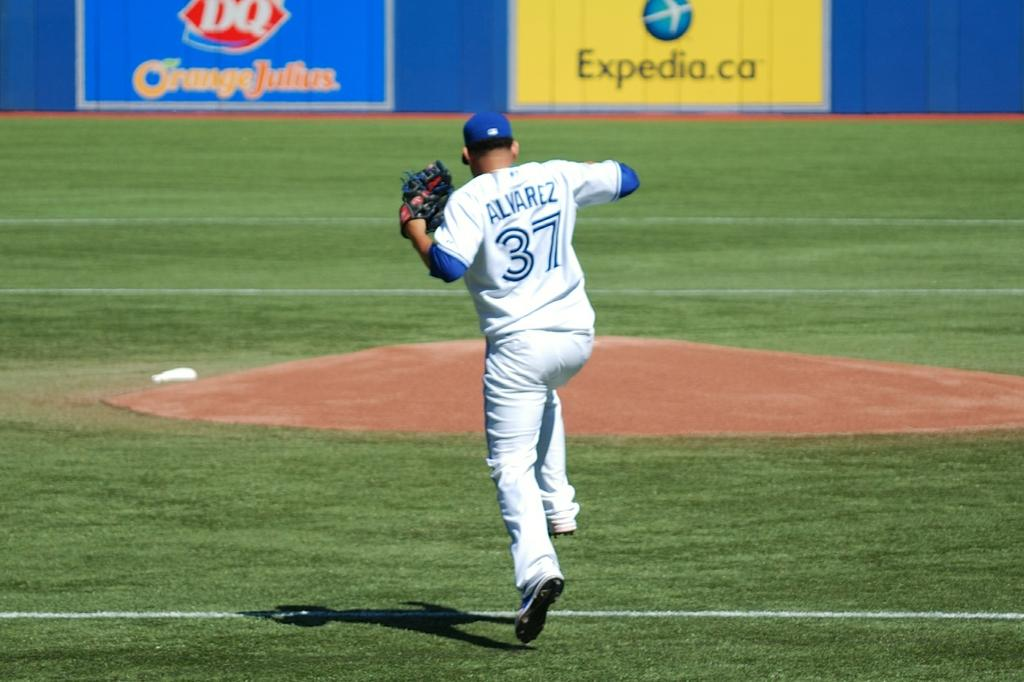Provide a one-sentence caption for the provided image. a baseball player who is in mid jump and is wearing a number 37 shirt. 